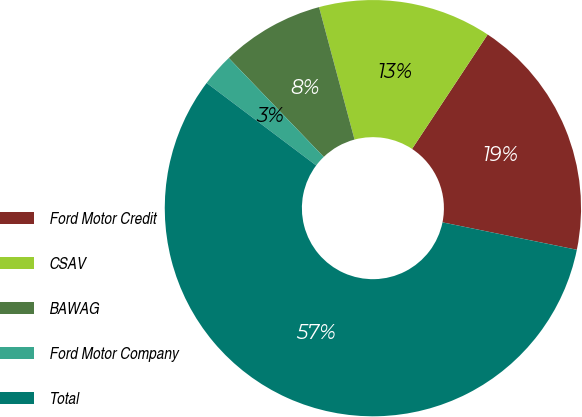Convert chart to OTSL. <chart><loc_0><loc_0><loc_500><loc_500><pie_chart><fcel>Ford Motor Credit<fcel>CSAV<fcel>BAWAG<fcel>Ford Motor Company<fcel>Total<nl><fcel>18.91%<fcel>13.46%<fcel>8.01%<fcel>2.55%<fcel>57.07%<nl></chart> 